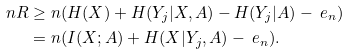<formula> <loc_0><loc_0><loc_500><loc_500>n R & \geq n ( H ( X ) + H ( Y _ { j } | X , A ) - H ( Y _ { j } | A ) - \ e _ { n } ) \\ & = n ( I ( X ; A ) + H ( X | Y _ { j } , A ) - \ e _ { n } ) .</formula> 